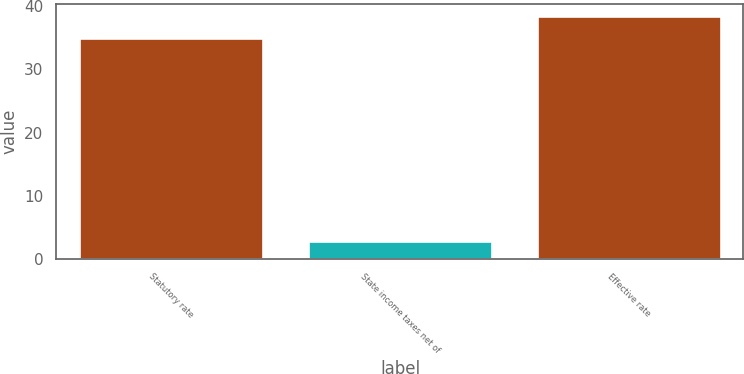Convert chart. <chart><loc_0><loc_0><loc_500><loc_500><bar_chart><fcel>Statutory rate<fcel>State income taxes net of<fcel>Effective rate<nl><fcel>35<fcel>2.75<fcel>38.42<nl></chart> 